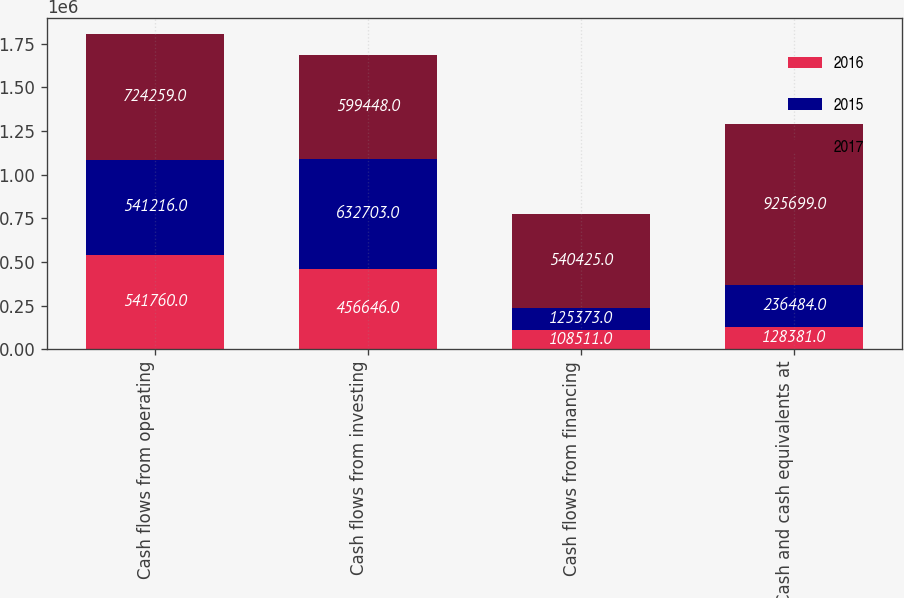<chart> <loc_0><loc_0><loc_500><loc_500><stacked_bar_chart><ecel><fcel>Cash flows from operating<fcel>Cash flows from investing<fcel>Cash flows from financing<fcel>Cash and cash equivalents at<nl><fcel>2016<fcel>541760<fcel>456646<fcel>108511<fcel>128381<nl><fcel>2015<fcel>541216<fcel>632703<fcel>125373<fcel>236484<nl><fcel>2017<fcel>724259<fcel>599448<fcel>540425<fcel>925699<nl></chart> 